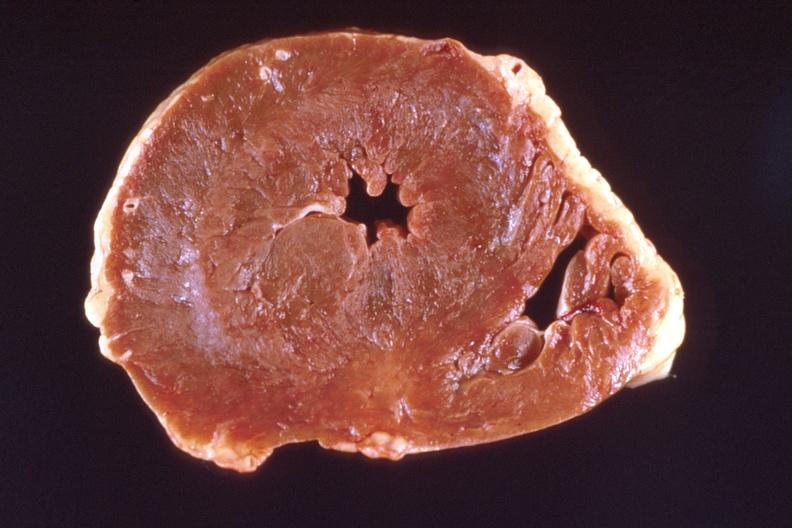s situs inversus left ventricular hypertrophy?
Answer the question using a single word or phrase. No 